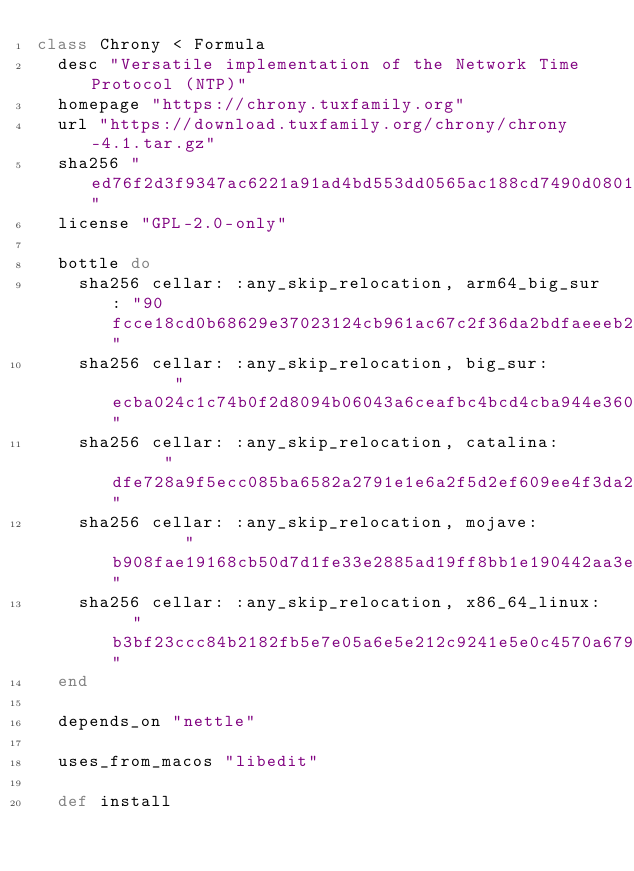Convert code to text. <code><loc_0><loc_0><loc_500><loc_500><_Ruby_>class Chrony < Formula
  desc "Versatile implementation of the Network Time Protocol (NTP)"
  homepage "https://chrony.tuxfamily.org"
  url "https://download.tuxfamily.org/chrony/chrony-4.1.tar.gz"
  sha256 "ed76f2d3f9347ac6221a91ad4bd553dd0565ac188cd7490d0801d08f7171164c"
  license "GPL-2.0-only"

  bottle do
    sha256 cellar: :any_skip_relocation, arm64_big_sur: "90fcce18cd0b68629e37023124cb961ac67c2f36da2bdfaeeeb2f6b146a49b9c"
    sha256 cellar: :any_skip_relocation, big_sur:       "ecba024c1c74b0f2d8094b06043a6ceafbc4bcd4cba944e3600792789adcfb4b"
    sha256 cellar: :any_skip_relocation, catalina:      "dfe728a9f5ecc085ba6582a2791e1e6a2f5d2ef609ee4f3da237e4442d016dbe"
    sha256 cellar: :any_skip_relocation, mojave:        "b908fae19168cb50d7d1fe33e2885ad19ff8bb1e190442aa3ee6ea6c47f4c72f"
    sha256 cellar: :any_skip_relocation, x86_64_linux:  "b3bf23ccc84b2182fb5e7e05a6e5e212c9241e5e0c4570a67929d8ac0f750a13"
  end

  depends_on "nettle"

  uses_from_macos "libedit"

  def install</code> 